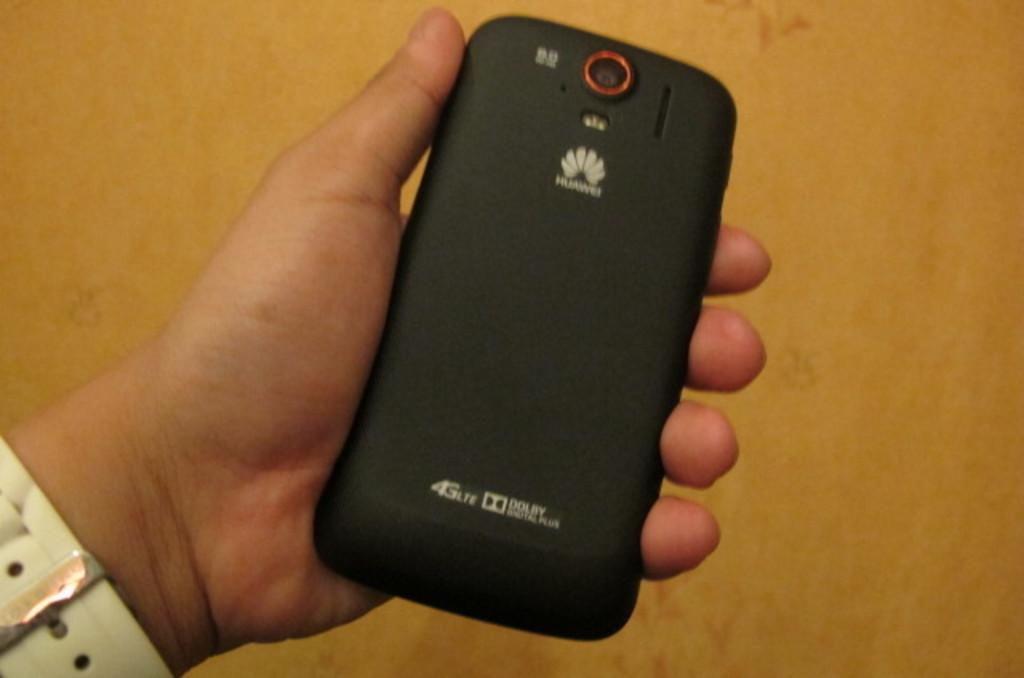<image>
Relay a brief, clear account of the picture shown. a dolby digital phone is being held by a person 